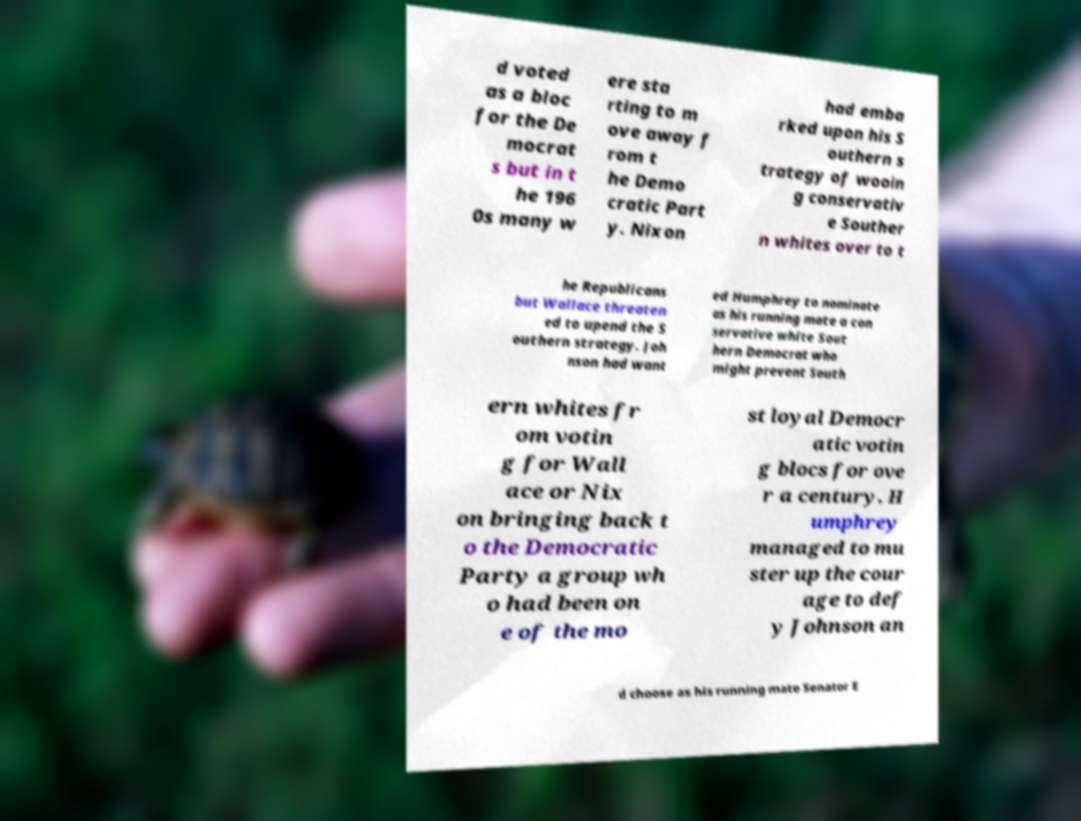There's text embedded in this image that I need extracted. Can you transcribe it verbatim? d voted as a bloc for the De mocrat s but in t he 196 0s many w ere sta rting to m ove away f rom t he Demo cratic Part y. Nixon had emba rked upon his S outhern s trategy of wooin g conservativ e Souther n whites over to t he Republicans but Wallace threaten ed to upend the S outhern strategy. Joh nson had want ed Humphrey to nominate as his running mate a con servative white Sout hern Democrat who might prevent South ern whites fr om votin g for Wall ace or Nix on bringing back t o the Democratic Party a group wh o had been on e of the mo st loyal Democr atic votin g blocs for ove r a century. H umphrey managed to mu ster up the cour age to def y Johnson an d choose as his running mate Senator E 